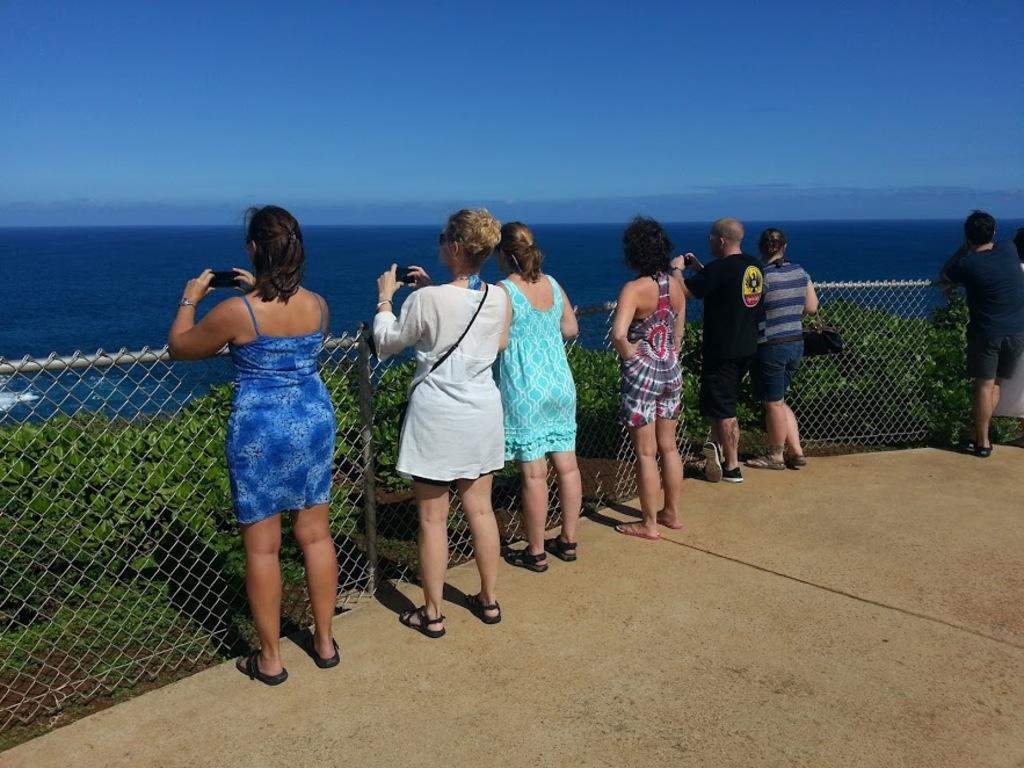In one or two sentences, can you explain what this image depicts? In this image there are people standing on the floor. In front of them there is a mesh. There are plants. In the background of the image there are water and sky. 